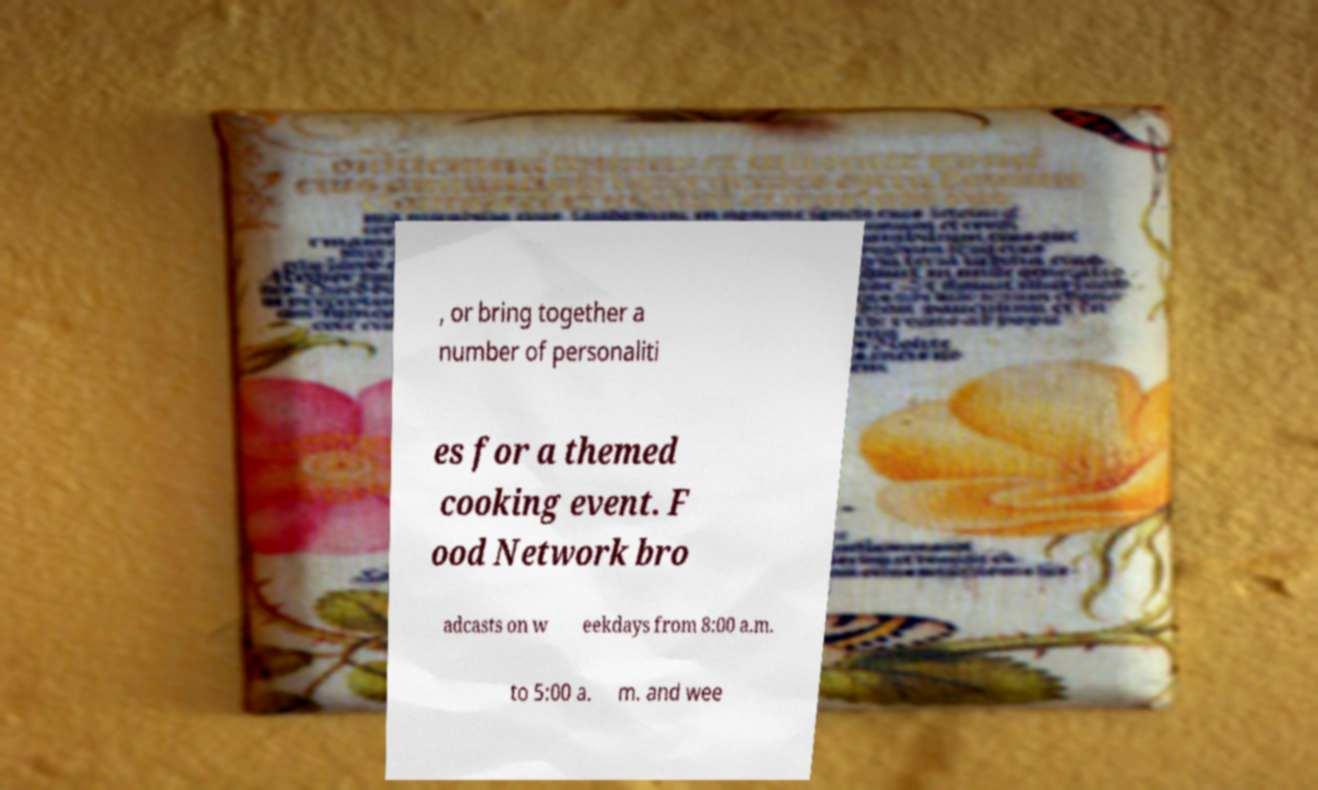What messages or text are displayed in this image? I need them in a readable, typed format. , or bring together a number of personaliti es for a themed cooking event. F ood Network bro adcasts on w eekdays from 8:00 a.m. to 5:00 a. m. and wee 